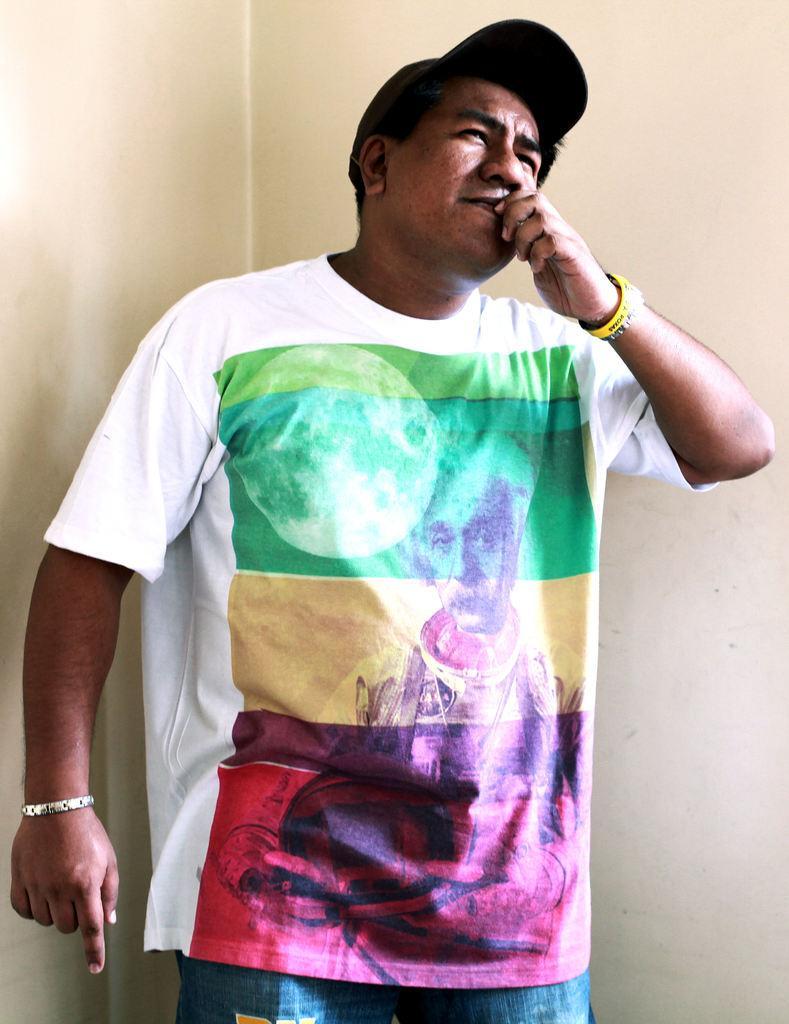Can you describe this image briefly? In this picture I can see there is a man standing here and he is wearing a white t-shirt and there are different colors on it, there is a picture of a man and a moon and he is wearing a cap and bracelets to his hands and in the backdrop there is a wall. 